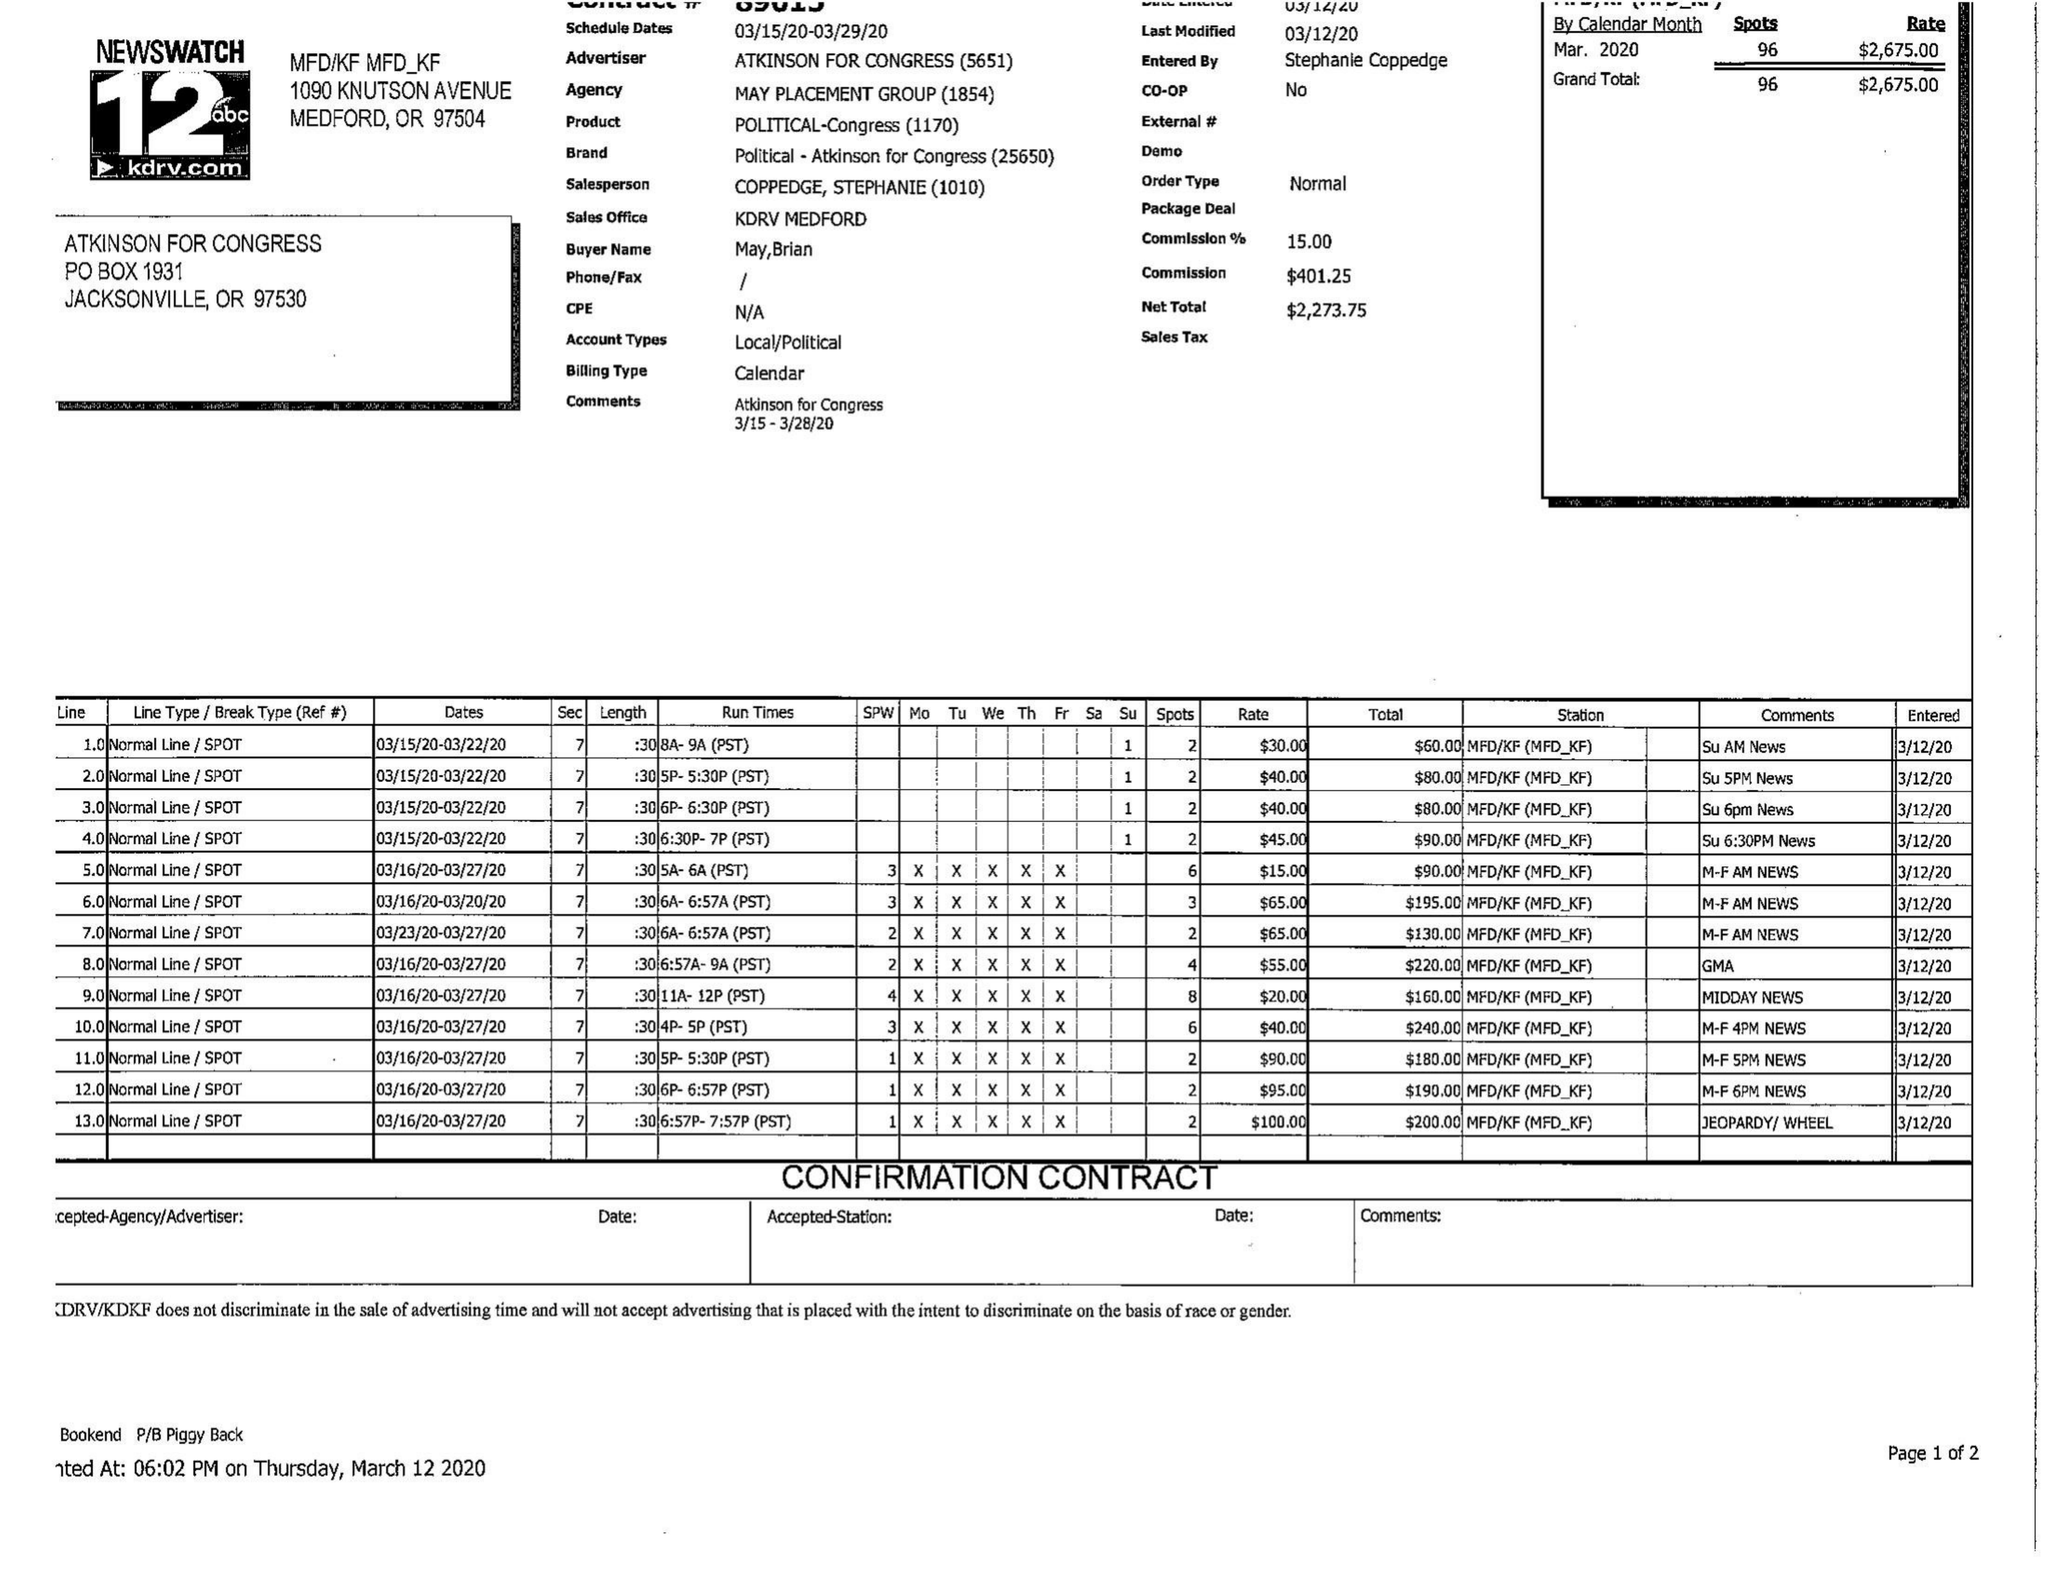What is the value for the gross_amount?
Answer the question using a single word or phrase. 2675.00 